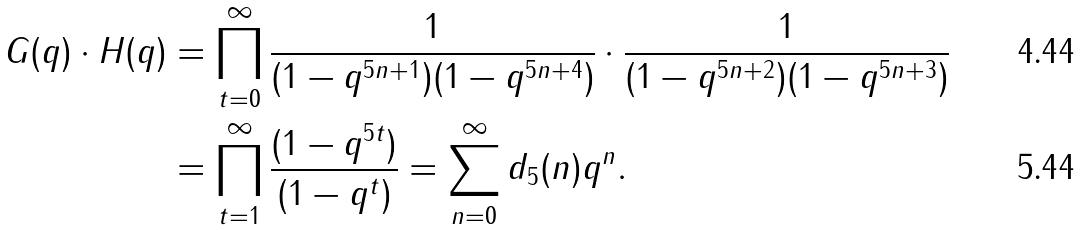<formula> <loc_0><loc_0><loc_500><loc_500>G ( q ) \cdot H ( q ) & = \prod _ { t = 0 } ^ { \infty } \frac { 1 } { ( 1 - q ^ { 5 n + 1 } ) ( 1 - q ^ { 5 n + 4 } ) } \cdot \frac { 1 } { ( 1 - q ^ { 5 n + 2 } ) ( 1 - q ^ { 5 n + 3 } ) } \\ & = \prod _ { t = 1 } ^ { \infty } \frac { ( 1 - q ^ { 5 t } ) } { ( 1 - q ^ { t } ) } = \sum _ { n = 0 } ^ { \infty } d _ { 5 } ( n ) q ^ { n } .</formula> 